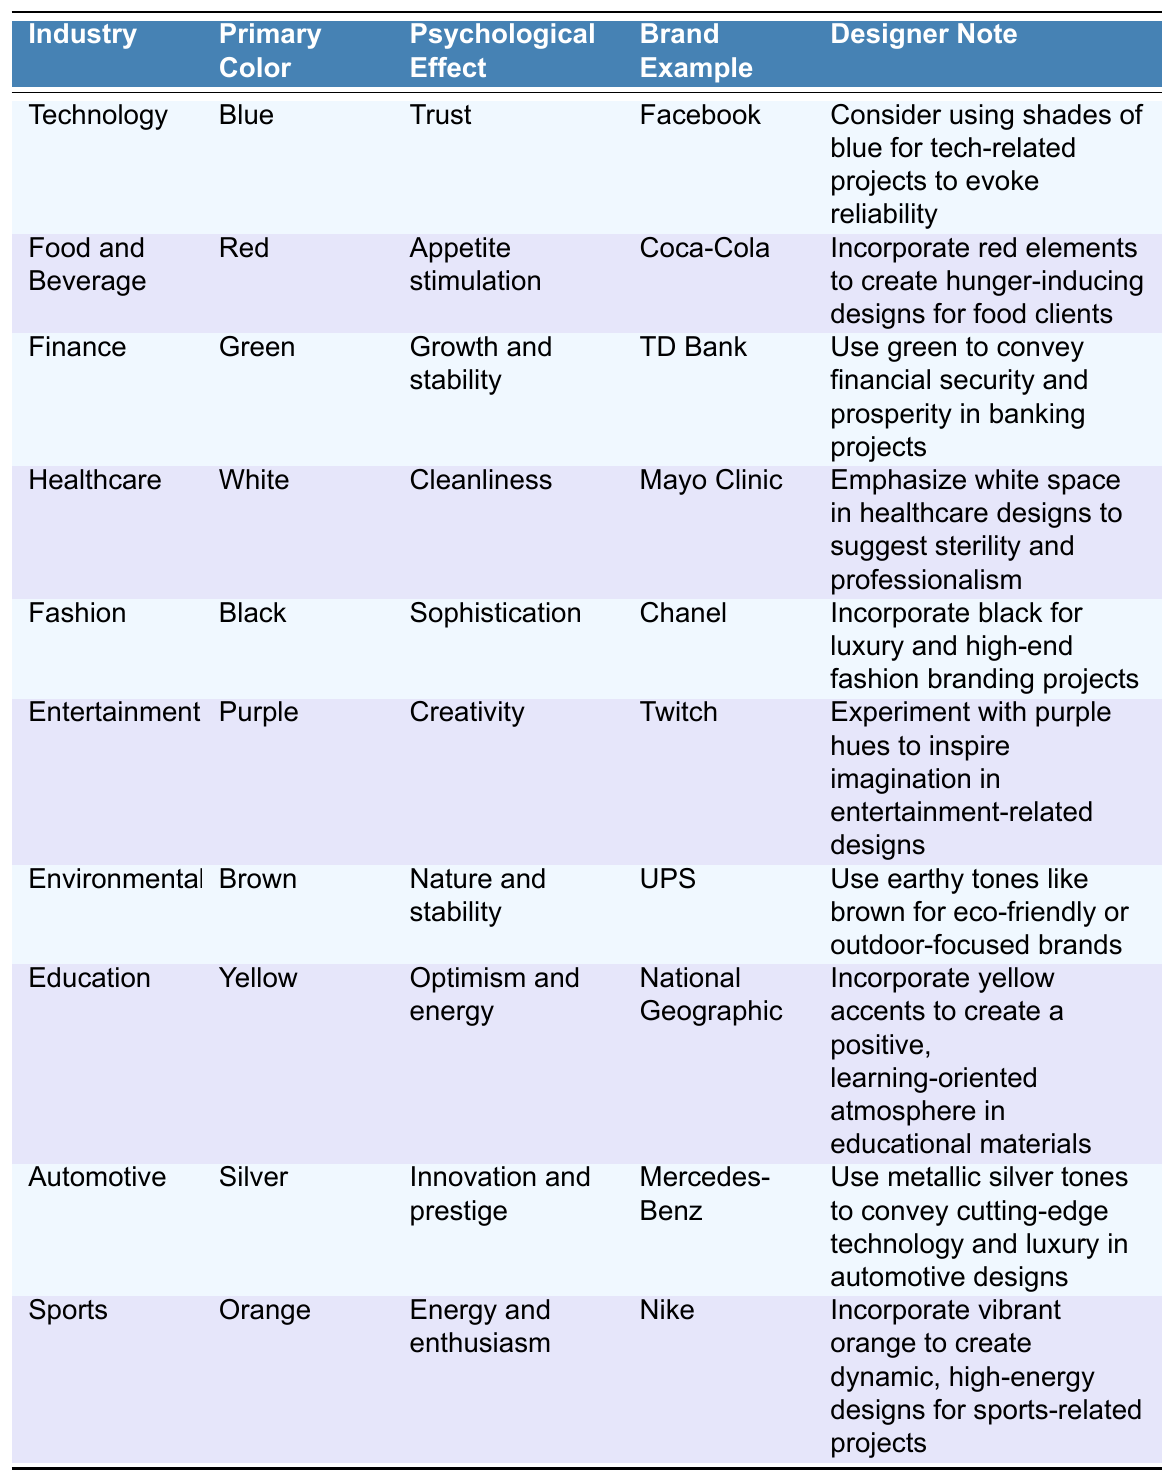What primary color is associated with the Technology industry? The table lists "Technology" under the Industry column, with "Blue" noted in the Primary Color column.
Answer: Blue Which brand example represents the Fashion industry? In the table, the Fashion industry is paired with "Chanel" in the Brand Example column.
Answer: Chanel What psychological effect is indicated by the color white in the Healthcare industry? Referring to the Healthcare row in the table, the Psychological Effect for white is "Cleanliness".
Answer: Cleanliness Is the primary color for the Automotive industry silver? The Automotive industry's primary color is listed as "Silver" in the table, confirming the statement is true.
Answer: Yes Which color is linked to the Education industry and what is its psychological effect? The Education row shows "Yellow" as the primary color and "Optimism and energy" as the psychological effect.
Answer: Yellow; Optimism and energy How many industries use the color blue as their primary color? The Technology industry is the only one in the table that lists blue as the primary color. Thus, there is only one industry.
Answer: 1 What color is used to represent trust in the Technology industry? The table states that "Blue" is the primary color associated with "Trust" in the Technology industry.
Answer: Blue If you wanted to create a design for a Food and Beverage brand, which color should you use for appetite stimulation? The Food and Beverage industry is associated with "Red", which is linked to "Appetite stimulation" in the Psychological Effect column.
Answer: Red Which industry uses purple and what psychological effect does it represent? According to the table, "Entertainment" uses "Purple" and it represents the psychological effect of "Creativity".
Answer: Entertainment; Creativity What is the difference in primary message conveyed by the primary colors used in the Finance and Environmental industries? The Finance industry uses "Green" for "Growth and stability", while the Environmental industry uses "Brown" for "Nature and stability", indicating that while both suggest stability, green emphasizes growth in finance.
Answer: Growth vs. Nature stability 